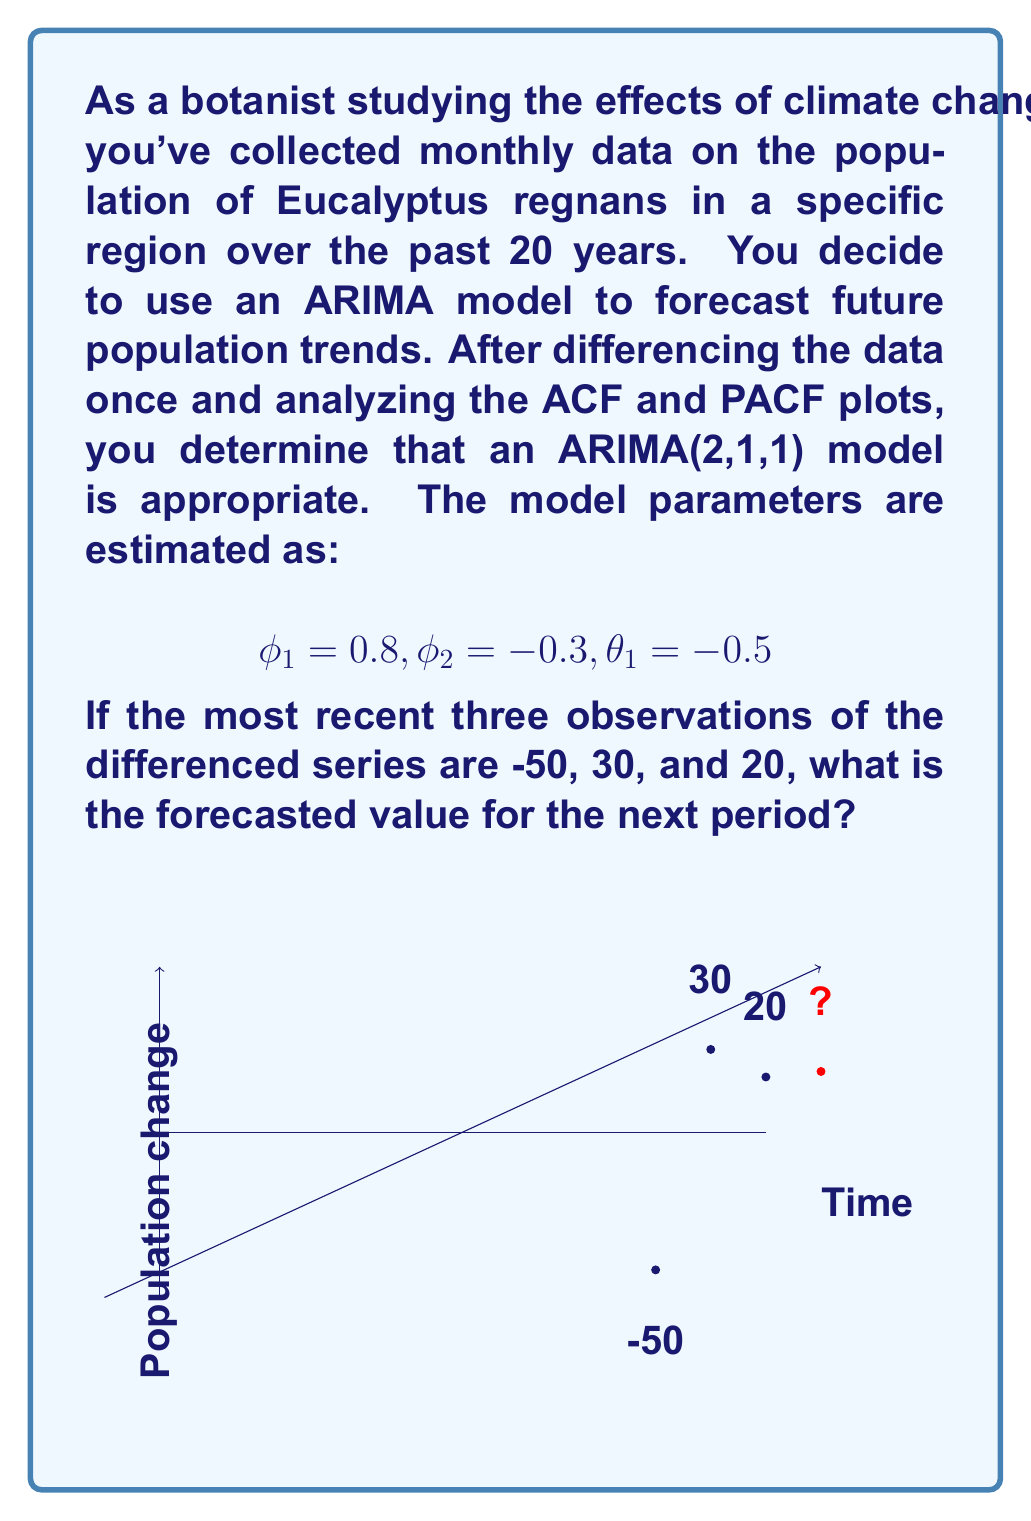Can you answer this question? Let's approach this step-by-step:

1) The general form of an ARIMA(2,1,1) model is:

   $$(1-B)(1-\phi_1B-\phi_2B^2)Y_t = (1-\theta_1B)\epsilon_t$$

   Where B is the backshift operator.

2) Expanding this, we get:

   $$Y_t - Y_{t-1} - \phi_1(Y_{t-1}-Y_{t-2}) - \phi_2(Y_{t-2}-Y_{t-3}) = \epsilon_t - \theta_1\epsilon_{t-1}$$

3) Rearranging to isolate $Y_t$:

   $$Y_t = Y_{t-1} + \phi_1(Y_{t-1}-Y_{t-2}) + \phi_2(Y_{t-2}-Y_{t-3}) + \epsilon_t - \theta_1\epsilon_{t-1}$$

4) Substituting the given parameters:

   $$Y_t = Y_{t-1} + 0.8(Y_{t-1}-Y_{t-2}) - 0.3(Y_{t-2}-Y_{t-3}) + \epsilon_t + 0.5\epsilon_{t-1}$$

5) We're given the last three observations of the differenced series. Let's call our forecast $Y_{t+1}$. Then:

   $Y_t = 20$
   $Y_{t-1} = 30$
   $Y_{t-2} = -50$

6) For the forecast, we assume future errors are zero: $\epsilon_{t+1} = 0$. We don't know $\epsilon_t$, but it's our most recent error, so we can estimate it as the difference between the actual value and what our model would have predicted:

   $$\epsilon_t = Y_t - (Y_{t-1} + 0.8(Y_{t-1}-Y_{t-2}) - 0.3(Y_{t-2}-Y_{t-3}))$$
   $$\epsilon_t = 20 - (30 + 0.8(30-(-50)) - 0.3(-50-Y_{t-3}))$$

   We don't know $Y_{t-3}$, but its effect is minimal due to the -0.3 coefficient, so let's assume it's close to $Y_{t-2}$ for simplicity.

   $$\epsilon_t \approx 20 - (30 + 0.8(80) - 0.3(0)) = 20 - 94 = -74$$

7) Now we can forecast $Y_{t+1}$:

   $$Y_{t+1} = 20 + 0.8(20-30) - 0.3(30-(-50)) + 0 + 0.5(-74)$$
   $$= 20 - 8 - 24 - 37 = -49$$

Thus, the forecasted value for the next period is -49.
Answer: -49 